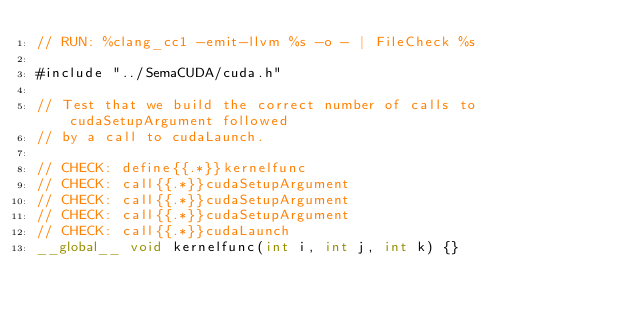Convert code to text. <code><loc_0><loc_0><loc_500><loc_500><_Cuda_>// RUN: %clang_cc1 -emit-llvm %s -o - | FileCheck %s

#include "../SemaCUDA/cuda.h"

// Test that we build the correct number of calls to cudaSetupArgument followed
// by a call to cudaLaunch.

// CHECK: define{{.*}}kernelfunc
// CHECK: call{{.*}}cudaSetupArgument
// CHECK: call{{.*}}cudaSetupArgument
// CHECK: call{{.*}}cudaSetupArgument
// CHECK: call{{.*}}cudaLaunch
__global__ void kernelfunc(int i, int j, int k) {}
</code> 